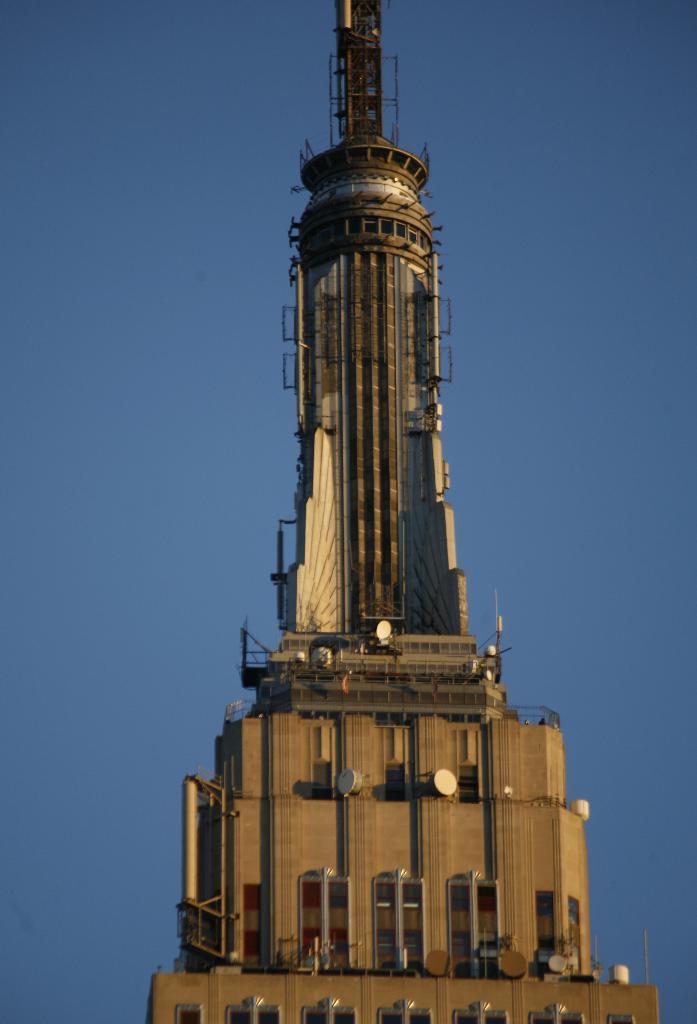How would you summarize this image in a sentence or two? In the background portion of the picture there is a clear blue sky. We can see a tower in this picture. 